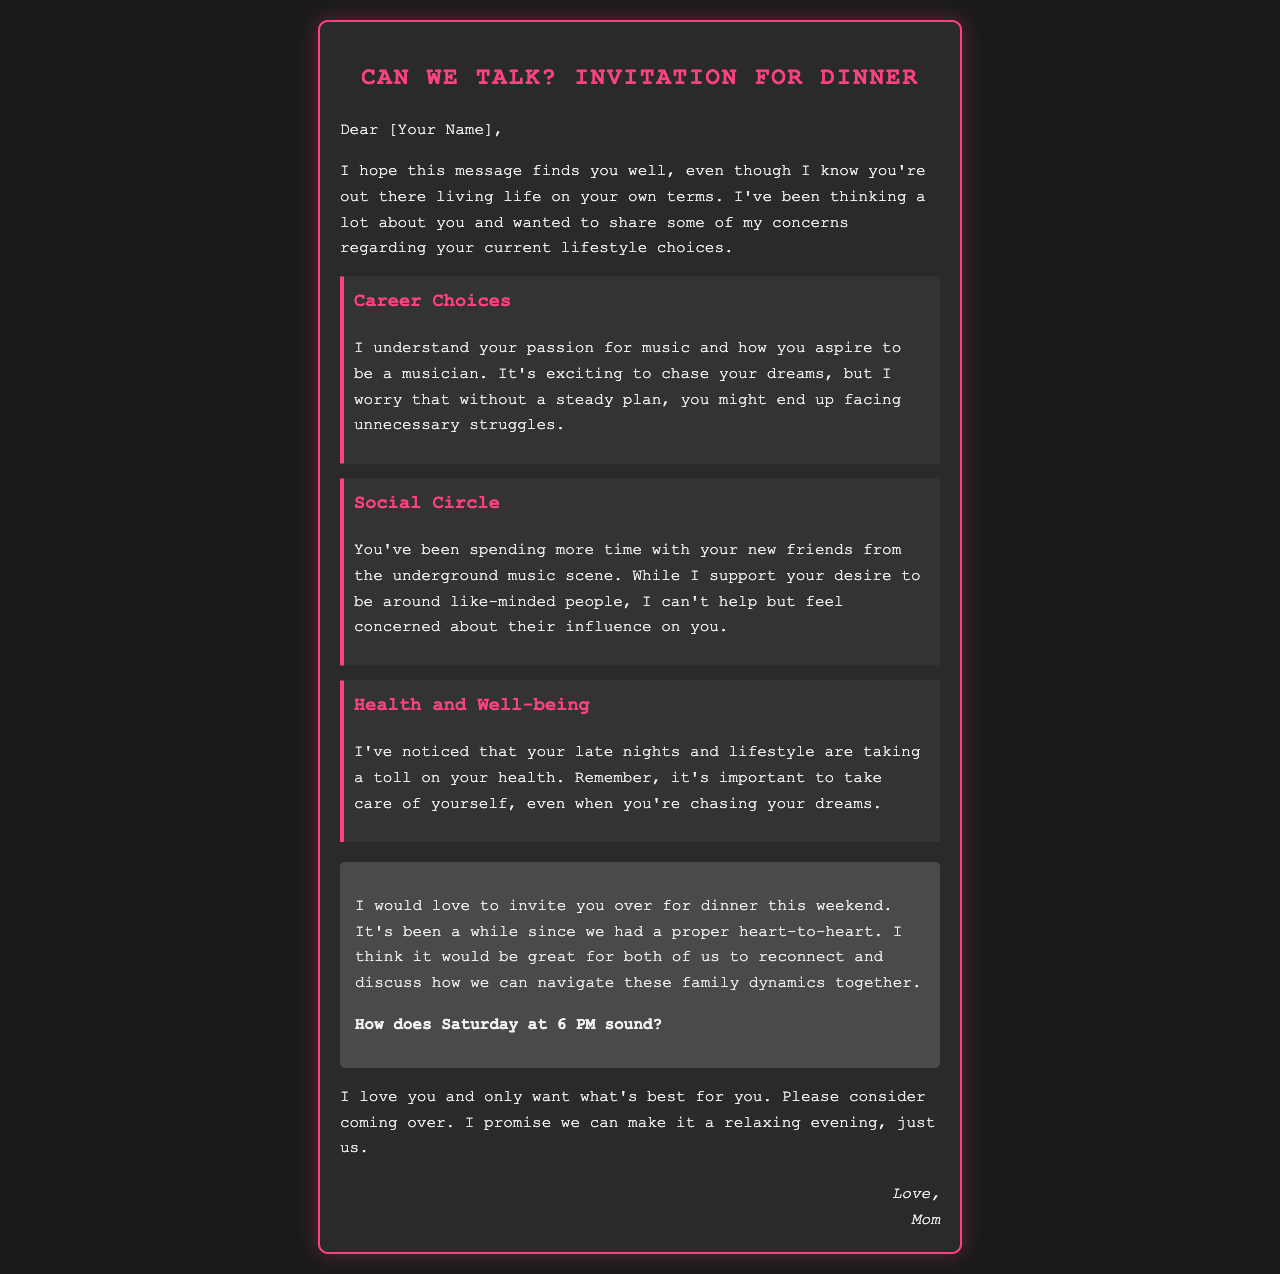What is the main concern mentioned about your career? The email addresses concerns about the recipient's passion for music and lack of a steady plan.
Answer: Steady plan What specific invitation is given in the email? The email invites the recipient over for dinner to discuss family dynamics.
Answer: Dinner this weekend What time is the dinner invitation suggested for? The suggested time for the dinner invitation is mentioned in the document.
Answer: Saturday at 6 PM Who is the author of the email? The email is signed off by a familial relationship, revealing the author.
Answer: Mom What is one aspect of health mentioned that the sender is worried about? The email highlights concern over the recipient's late nights and lifestyle affecting health.
Answer: Health What are the recipients of the email encouraged to consider? The sender expresses a desire for the recipient to consider visiting for dinner.
Answer: Coming over What style of music is referenced in the email? The email mentions a specific community related to the recipient's social circle.
Answer: Underground music scene What is the tone of the email? The overall tone of the email reflects a caring and concerned approach from the sender toward the recipient's lifestyle.
Answer: Caring 